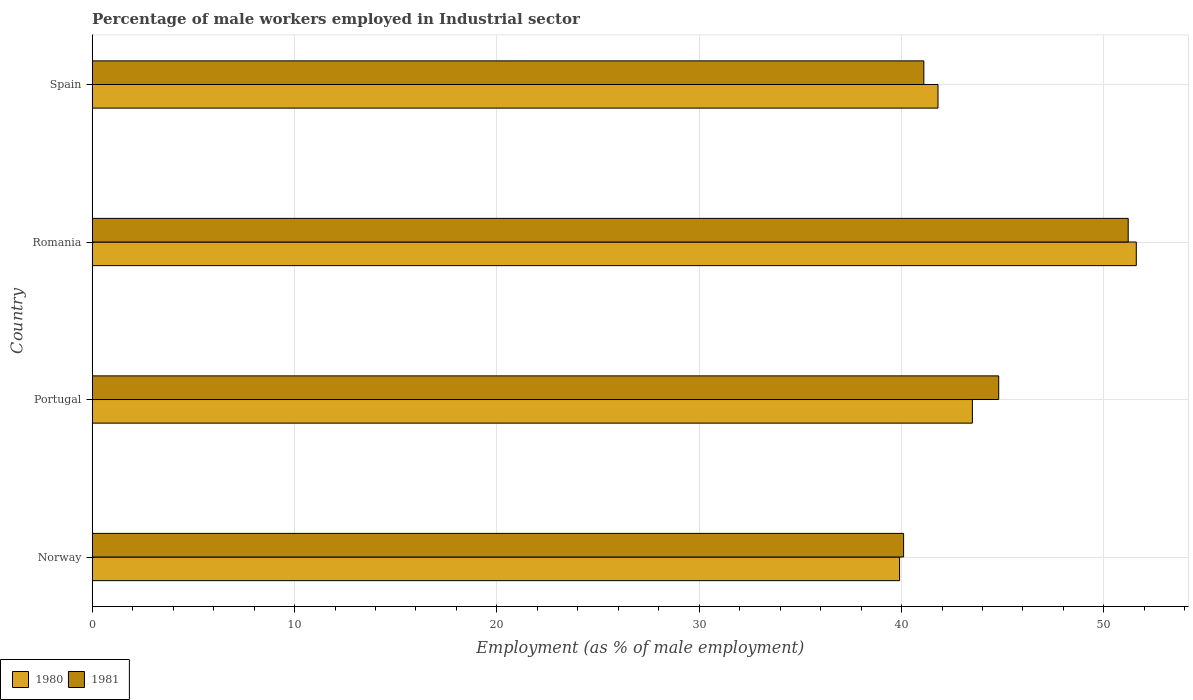How many groups of bars are there?
Offer a very short reply. 4. Are the number of bars on each tick of the Y-axis equal?
Offer a terse response. Yes. How many bars are there on the 1st tick from the bottom?
Your answer should be very brief. 2. What is the label of the 1st group of bars from the top?
Provide a short and direct response. Spain. In how many cases, is the number of bars for a given country not equal to the number of legend labels?
Your response must be concise. 0. What is the percentage of male workers employed in Industrial sector in 1981 in Romania?
Ensure brevity in your answer.  51.2. Across all countries, what is the maximum percentage of male workers employed in Industrial sector in 1980?
Your response must be concise. 51.6. Across all countries, what is the minimum percentage of male workers employed in Industrial sector in 1980?
Make the answer very short. 39.9. In which country was the percentage of male workers employed in Industrial sector in 1980 maximum?
Offer a very short reply. Romania. What is the total percentage of male workers employed in Industrial sector in 1981 in the graph?
Provide a short and direct response. 177.2. What is the difference between the percentage of male workers employed in Industrial sector in 1981 in Norway and that in Romania?
Your response must be concise. -11.1. What is the difference between the percentage of male workers employed in Industrial sector in 1981 in Romania and the percentage of male workers employed in Industrial sector in 1980 in Norway?
Provide a succinct answer. 11.3. What is the average percentage of male workers employed in Industrial sector in 1981 per country?
Provide a succinct answer. 44.3. What is the difference between the percentage of male workers employed in Industrial sector in 1981 and percentage of male workers employed in Industrial sector in 1980 in Portugal?
Provide a short and direct response. 1.3. In how many countries, is the percentage of male workers employed in Industrial sector in 1980 greater than 24 %?
Ensure brevity in your answer.  4. What is the ratio of the percentage of male workers employed in Industrial sector in 1981 in Portugal to that in Spain?
Make the answer very short. 1.09. Is the percentage of male workers employed in Industrial sector in 1981 in Norway less than that in Spain?
Offer a very short reply. Yes. What is the difference between the highest and the second highest percentage of male workers employed in Industrial sector in 1981?
Your response must be concise. 6.4. What is the difference between the highest and the lowest percentage of male workers employed in Industrial sector in 1981?
Give a very brief answer. 11.1. Is the sum of the percentage of male workers employed in Industrial sector in 1981 in Romania and Spain greater than the maximum percentage of male workers employed in Industrial sector in 1980 across all countries?
Keep it short and to the point. Yes. What does the 2nd bar from the top in Norway represents?
Your response must be concise. 1980. How many bars are there?
Your answer should be very brief. 8. Are all the bars in the graph horizontal?
Ensure brevity in your answer.  Yes. How many countries are there in the graph?
Your answer should be compact. 4. What is the difference between two consecutive major ticks on the X-axis?
Provide a short and direct response. 10. Are the values on the major ticks of X-axis written in scientific E-notation?
Your answer should be compact. No. Does the graph contain grids?
Your answer should be compact. Yes. What is the title of the graph?
Provide a succinct answer. Percentage of male workers employed in Industrial sector. What is the label or title of the X-axis?
Your answer should be compact. Employment (as % of male employment). What is the Employment (as % of male employment) of 1980 in Norway?
Provide a succinct answer. 39.9. What is the Employment (as % of male employment) in 1981 in Norway?
Provide a succinct answer. 40.1. What is the Employment (as % of male employment) of 1980 in Portugal?
Ensure brevity in your answer.  43.5. What is the Employment (as % of male employment) of 1981 in Portugal?
Keep it short and to the point. 44.8. What is the Employment (as % of male employment) of 1980 in Romania?
Provide a short and direct response. 51.6. What is the Employment (as % of male employment) in 1981 in Romania?
Make the answer very short. 51.2. What is the Employment (as % of male employment) of 1980 in Spain?
Offer a terse response. 41.8. What is the Employment (as % of male employment) of 1981 in Spain?
Your answer should be compact. 41.1. Across all countries, what is the maximum Employment (as % of male employment) of 1980?
Offer a terse response. 51.6. Across all countries, what is the maximum Employment (as % of male employment) of 1981?
Give a very brief answer. 51.2. Across all countries, what is the minimum Employment (as % of male employment) in 1980?
Your answer should be compact. 39.9. Across all countries, what is the minimum Employment (as % of male employment) in 1981?
Keep it short and to the point. 40.1. What is the total Employment (as % of male employment) in 1980 in the graph?
Give a very brief answer. 176.8. What is the total Employment (as % of male employment) in 1981 in the graph?
Offer a very short reply. 177.2. What is the difference between the Employment (as % of male employment) in 1980 in Portugal and that in Romania?
Provide a short and direct response. -8.1. What is the difference between the Employment (as % of male employment) of 1980 in Romania and that in Spain?
Keep it short and to the point. 9.8. What is the difference between the Employment (as % of male employment) in 1981 in Romania and that in Spain?
Make the answer very short. 10.1. What is the difference between the Employment (as % of male employment) in 1980 in Portugal and the Employment (as % of male employment) in 1981 in Spain?
Keep it short and to the point. 2.4. What is the average Employment (as % of male employment) in 1980 per country?
Provide a short and direct response. 44.2. What is the average Employment (as % of male employment) of 1981 per country?
Give a very brief answer. 44.3. What is the difference between the Employment (as % of male employment) of 1980 and Employment (as % of male employment) of 1981 in Portugal?
Offer a terse response. -1.3. What is the difference between the Employment (as % of male employment) in 1980 and Employment (as % of male employment) in 1981 in Romania?
Make the answer very short. 0.4. What is the difference between the Employment (as % of male employment) in 1980 and Employment (as % of male employment) in 1981 in Spain?
Your answer should be very brief. 0.7. What is the ratio of the Employment (as % of male employment) in 1980 in Norway to that in Portugal?
Your answer should be very brief. 0.92. What is the ratio of the Employment (as % of male employment) of 1981 in Norway to that in Portugal?
Offer a very short reply. 0.9. What is the ratio of the Employment (as % of male employment) of 1980 in Norway to that in Romania?
Your answer should be compact. 0.77. What is the ratio of the Employment (as % of male employment) in 1981 in Norway to that in Romania?
Provide a short and direct response. 0.78. What is the ratio of the Employment (as % of male employment) of 1980 in Norway to that in Spain?
Offer a terse response. 0.95. What is the ratio of the Employment (as % of male employment) in 1981 in Norway to that in Spain?
Ensure brevity in your answer.  0.98. What is the ratio of the Employment (as % of male employment) of 1980 in Portugal to that in Romania?
Your answer should be compact. 0.84. What is the ratio of the Employment (as % of male employment) of 1980 in Portugal to that in Spain?
Keep it short and to the point. 1.04. What is the ratio of the Employment (as % of male employment) in 1981 in Portugal to that in Spain?
Your response must be concise. 1.09. What is the ratio of the Employment (as % of male employment) in 1980 in Romania to that in Spain?
Your answer should be very brief. 1.23. What is the ratio of the Employment (as % of male employment) of 1981 in Romania to that in Spain?
Your answer should be very brief. 1.25. What is the difference between the highest and the lowest Employment (as % of male employment) of 1981?
Offer a terse response. 11.1. 